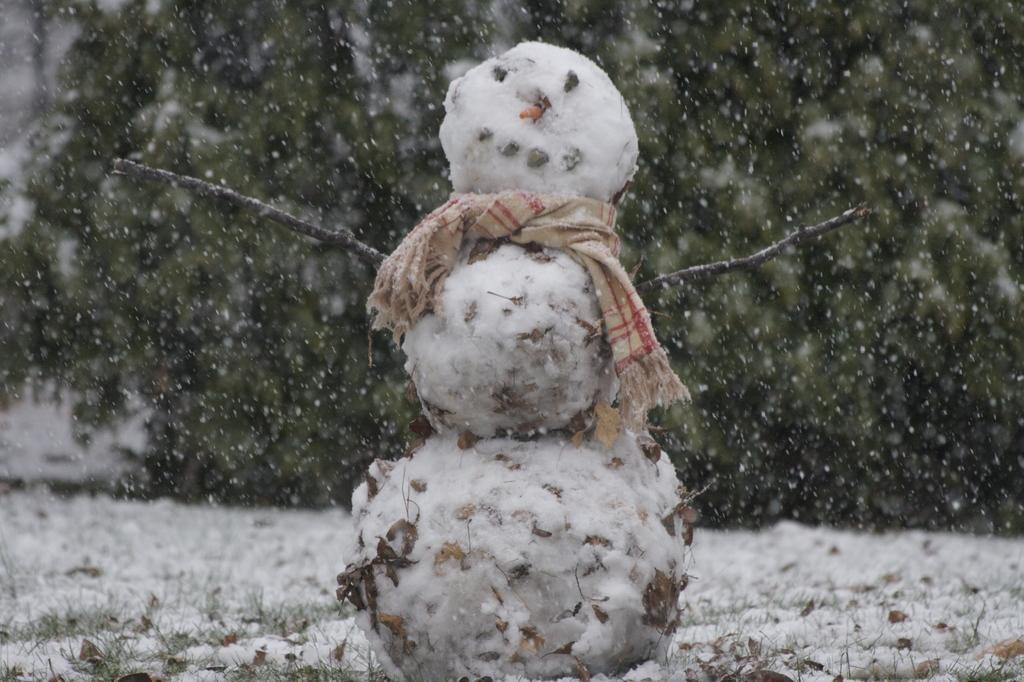Could you give a brief overview of what you see in this image? In this picture there is a snowman in the foreground. At the back there is a tree. At the bottom there is snow. 